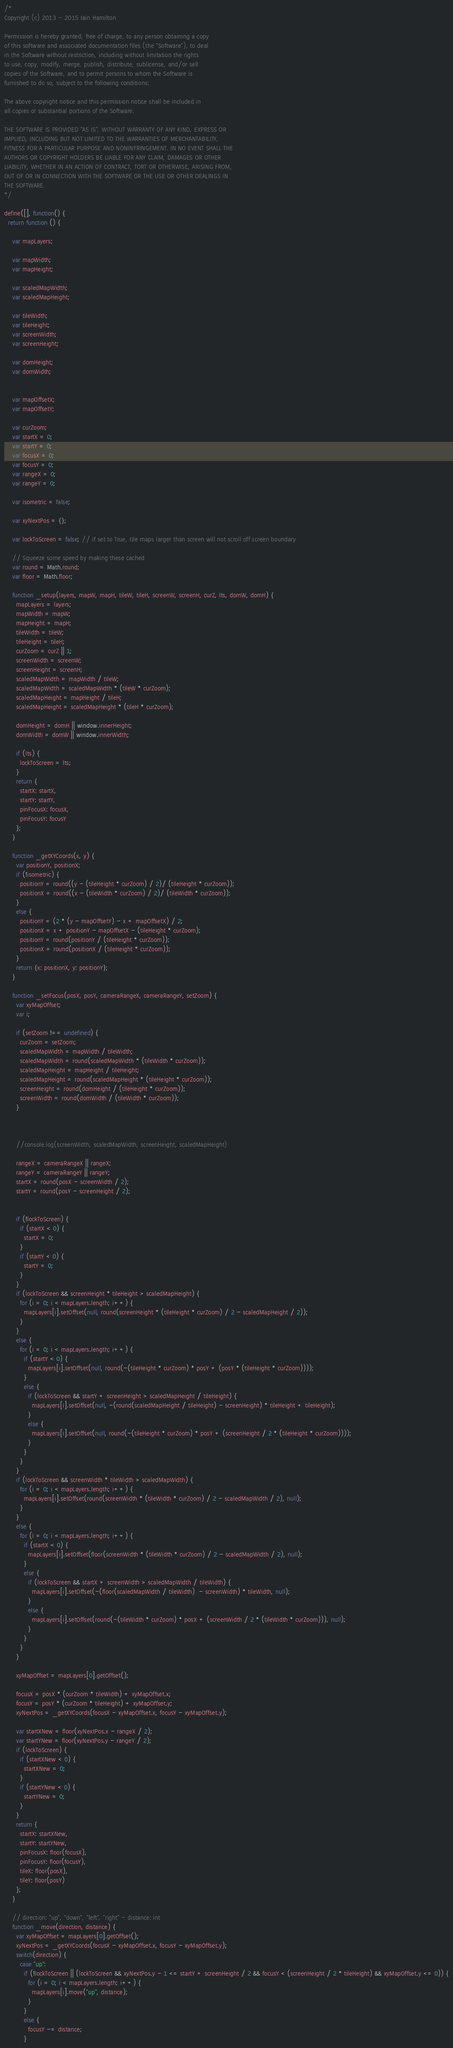Convert code to text. <code><loc_0><loc_0><loc_500><loc_500><_JavaScript_>/*  
Copyright (c) 2013 - 2015 Iain Hamilton

Permission is hereby granted, free of charge, to any person obtaining a copy
of this software and associated documentation files (the "Software"), to deal
in the Software without restriction, including without limitation the rights
to use, copy, modify, merge, publish, distribute, sublicense, and/or sell
copies of the Software, and to permit persons to whom the Software is
furnished to do so, subject to the following conditions:

The above copyright notice and this permission notice shall be included in
all copies or substantial portions of the Software.

THE SOFTWARE IS PROVIDED "AS IS", WITHOUT WARRANTY OF ANY KIND, EXPRESS OR
IMPLIED, INCLUDING BUT NOT LIMITED TO THE WARRANTIES OF MERCHANTABILITY,
FITNESS FOR A PARTICULAR PURPOSE AND NONINFRINGEMENT. IN NO EVENT SHALL THE
AUTHORS OR COPYRIGHT HOLDERS BE LIABLE FOR ANY CLAIM, DAMAGES OR OTHER
LIABILITY, WHETHER IN AN ACTION OF CONTRACT, TORT OR OTHERWISE, ARISING FROM,
OUT OF OR IN CONNECTION WITH THE SOFTWARE OR THE USE OR OTHER DEALINGS IN
THE SOFTWARE. 
*/

define([], function() {
  return function () {

    var mapLayers;

    var mapWidth;
    var mapHeight;

    var scaledMapWidth;
    var scaledMapHeight;

    var tileWidth;
    var tileHeight;
    var screenWidth;
    var screenHeight;

    var domHeight;
    var domWidth;


    var mapOffsetX;
    var mapOffsetY;

    var curZoom;
    var startX = 0;
    var startY = 0;
    var focusX = 0;
    var focusY = 0;
    var rangeX = 0;
    var rangeY = 0;
    
    var isometric = false;

    var xyNextPos = {};

    var lockToScreen = false; // if set to True, tile maps larger than screen will not scroll off screen boundary

    // Squeeze some speed by making these cached
    var round = Math.round;
    var floor = Math.floor;

    function _setup(layers, mapW, mapH, tileW, tileH, screenW, screenH, curZ, lts, domW, domH) {
      mapLayers = layers;
      mapWidth = mapW;
      mapHeight = mapH;
      tileWidth = tileW;
      tileHeight = tileH;
      curZoom = curZ || 1;
      screenWidth = screenW;
      screenHeight = screenH;
      scaledMapWidth = mapWidth / tileW;
      scaledMapWidth = scaledMapWidth * (tileW * curZoom);
      scaledMapHeight = mapHeight / tileH;
      scaledMapHeight = scaledMapHeight * (tileH * curZoom);

      domHeight = domH || window.innerHeight;
      domWidth = domW || window.innerWidth;

      if (lts) {
        lockToScreen = lts;
      }
      return {
        startX: startX,
        startY: startY,
        pinFocusX: focusX,
        pinFocusY: focusY
      };
    }

    function _getXYCoords(x, y) {
      var positionY, positionX;
      if (!isometric) {
        positionY = round((y - (tileHeight * curZoom) / 2)/ (tileHeight * curZoom));
        positionX = round((x - (tileWidth * curZoom) / 2)/ (tileWidth * curZoom));
      }
      else {
        positionY = (2 * (y - mapOffsetY) - x + mapOffsetX) / 2;
        positionX = x + positionY - mapOffsetX - (tileHeight * curZoom);
        positionY = round(positionY / (tileHeight * curZoom));
        positionX = round(positionX / (tileHeight * curZoom));
      }
      return {x: positionX, y: positionY};
    }

    function _setFocus(posX, posY, cameraRangeX, cameraRangeY, setZoom) {
      var xyMapOffset;
      var i;

      if (setZoom !== undefined) {
        curZoom = setZoom;
        scaledMapWidth = mapWidth / tileWidth;
        scaledMapWidth = round(scaledMapWidth * (tileWidth * curZoom));
        scaledMapHeight = mapHeight / tileHeight;
        scaledMapHeight = round(scaledMapHeight * (tileHeight * curZoom));
        screenHeight = round(domHeight / (tileHeight * curZoom));
        screenWidth = round(domWidth / (tileWidth * curZoom));
      }



      //console.log(screenWidth, scaledMapWidth, screenHeight, scaledMapHeight)

      rangeX = cameraRangeX || rangeX;
      rangeY = cameraRangeY || rangeY;
      startX = round(posX - screenWidth / 2);
      startY = round(posY - screenHeight / 2);


      if (!lockToScreen) {
        if (startX < 0) {
          startX = 0;
        }
        if (startY < 0) {
          startY = 0;
        }
      }
      if (lockToScreen && screenHeight * tileHeight > scaledMapHeight) {
        for (i = 0; i < mapLayers.length; i++) {
          mapLayers[i].setOffset(null, round(screenHeight * (tileHeight * curZoom) / 2 - scaledMapHeight / 2));
        }
      }
      else {
        for (i = 0; i < mapLayers.length; i++) {
          if (startY < 0) {
            mapLayers[i].setOffset(null, round(-(tileHeight * curZoom) * posY + (posY * (tileHeight * curZoom))));
          }
          else {
            if (lockToScreen && startY + screenHeight > scaledMapHeight / tileHeight) {
              mapLayers[i].setOffset(null, -(round(scaledMapHeight / tileHeight) - screenHeight) * tileHeight + tileHeight);
            }
            else {
              mapLayers[i].setOffset(null, round(-(tileHeight * curZoom) * posY + (screenHeight / 2 * (tileHeight * curZoom))));
            }
          }
        }
      }
      if (lockToScreen && screenWidth * tileWidth > scaledMapWidth) {
        for (i = 0; i < mapLayers.length; i++) {
          mapLayers[i].setOffset(round(screenWidth * (tileWidth * curZoom) / 2 - scaledMapWidth / 2), null);
        }
      }
      else {
        for (i = 0; i < mapLayers.length; i++) {
          if (startX < 0) {
            mapLayers[i].setOffset(floor(screenWidth * (tileWidth * curZoom) / 2 - scaledMapWidth / 2), null);
          }
          else {
            if (lockToScreen && startX + screenWidth > scaledMapWidth / tileWidth) {
              mapLayers[i].setOffset(-(floor(scaledMapWidth / tileWidth)  - screenWidth) * tileWidth, null);
            }
            else {
              mapLayers[i].setOffset(round(-(tileWidth * curZoom) * posX + (screenWidth / 2 * (tileWidth * curZoom))), null);
            }
          }
        }
      }

      xyMapOffset = mapLayers[0].getOffset();

      focusX = posX * (curZoom * tileWidth) + xyMapOffset.x;
      focusY = posY * (curZoom * tileHeight) + xyMapOffset.y;
      xyNextPos = _getXYCoords(focusX - xyMapOffset.x, focusY - xyMapOffset.y);

      var startXNew = floor(xyNextPos.x - rangeX / 2);
      var startYNew = floor(xyNextPos.y - rangeY / 2);
      if (lockToScreen) {
        if (startXNew < 0) {
          startXNew = 0;
        }
        if (startYNew < 0) {
          startYNew = 0;
        }
      }
      return {
        startX: startXNew,
        startY: startYNew,
        pinFocusX: floor(focusX),
        pinFocusY: floor(focusY),
        tileX: floor(posX),
        tileY: floor(posY)
      };
    }

    // direction: "up", "down", "left", "right" - distance: int
    function _move(direction, distance) {
      var xyMapOffset = mapLayers[0].getOffset();
      xyNextPos = _getXYCoords(focusX - xyMapOffset.x, focusY - xyMapOffset.y);
      switch(direction) {
        case "up":
          if (!lockToScreen || (lockToScreen && xyNextPos.y - 1 <= startY + screenHeight / 2 && focusY < (screenHeight / 2 * tileHeight) && xyMapOffset.y <= 0)) {
            for (i = 0; i < mapLayers.length; i++) {
              mapLayers[i].move("up", distance);
            }
          }
          else {
            focusY -= distance;
          }</code> 